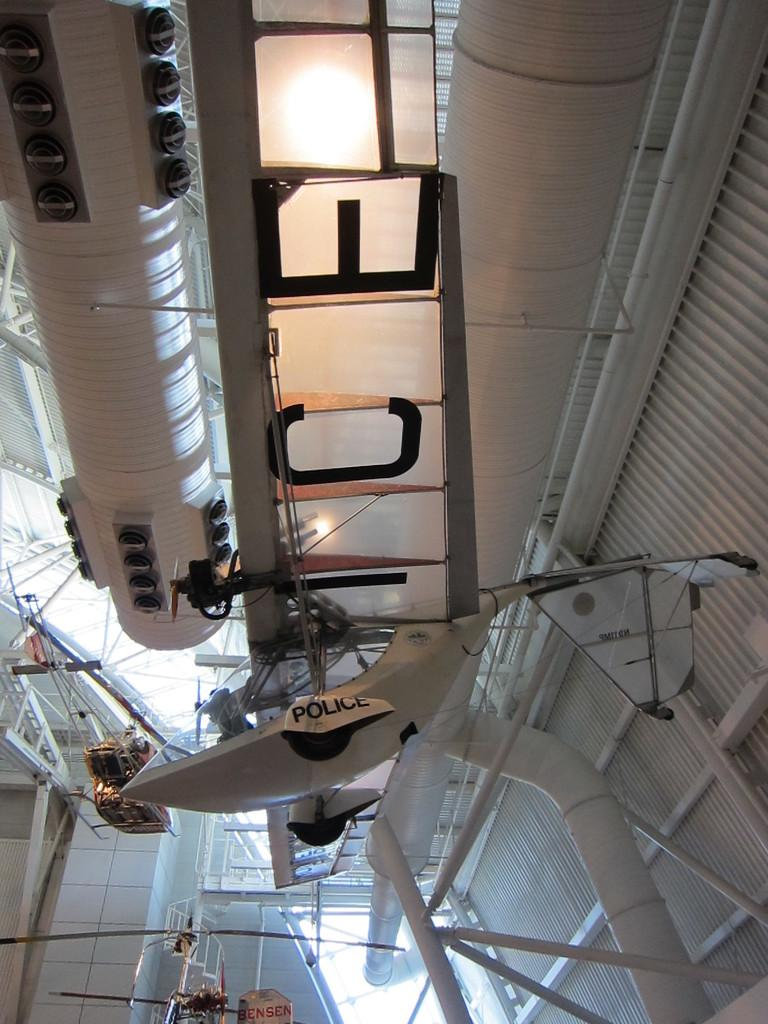What type of doors are present in the image? There are metal doors in the image. What other structures can be seen in the image? There are pipelines, grills, a staircase, and railings in the image. What is the most unusual object present in the image? There is a helicopter in the image. Where is the advertisement for the tent located in the image? There is no advertisement or tent present in the image. What color is the eye of the person in the image? There is no person or eye present in the image. 